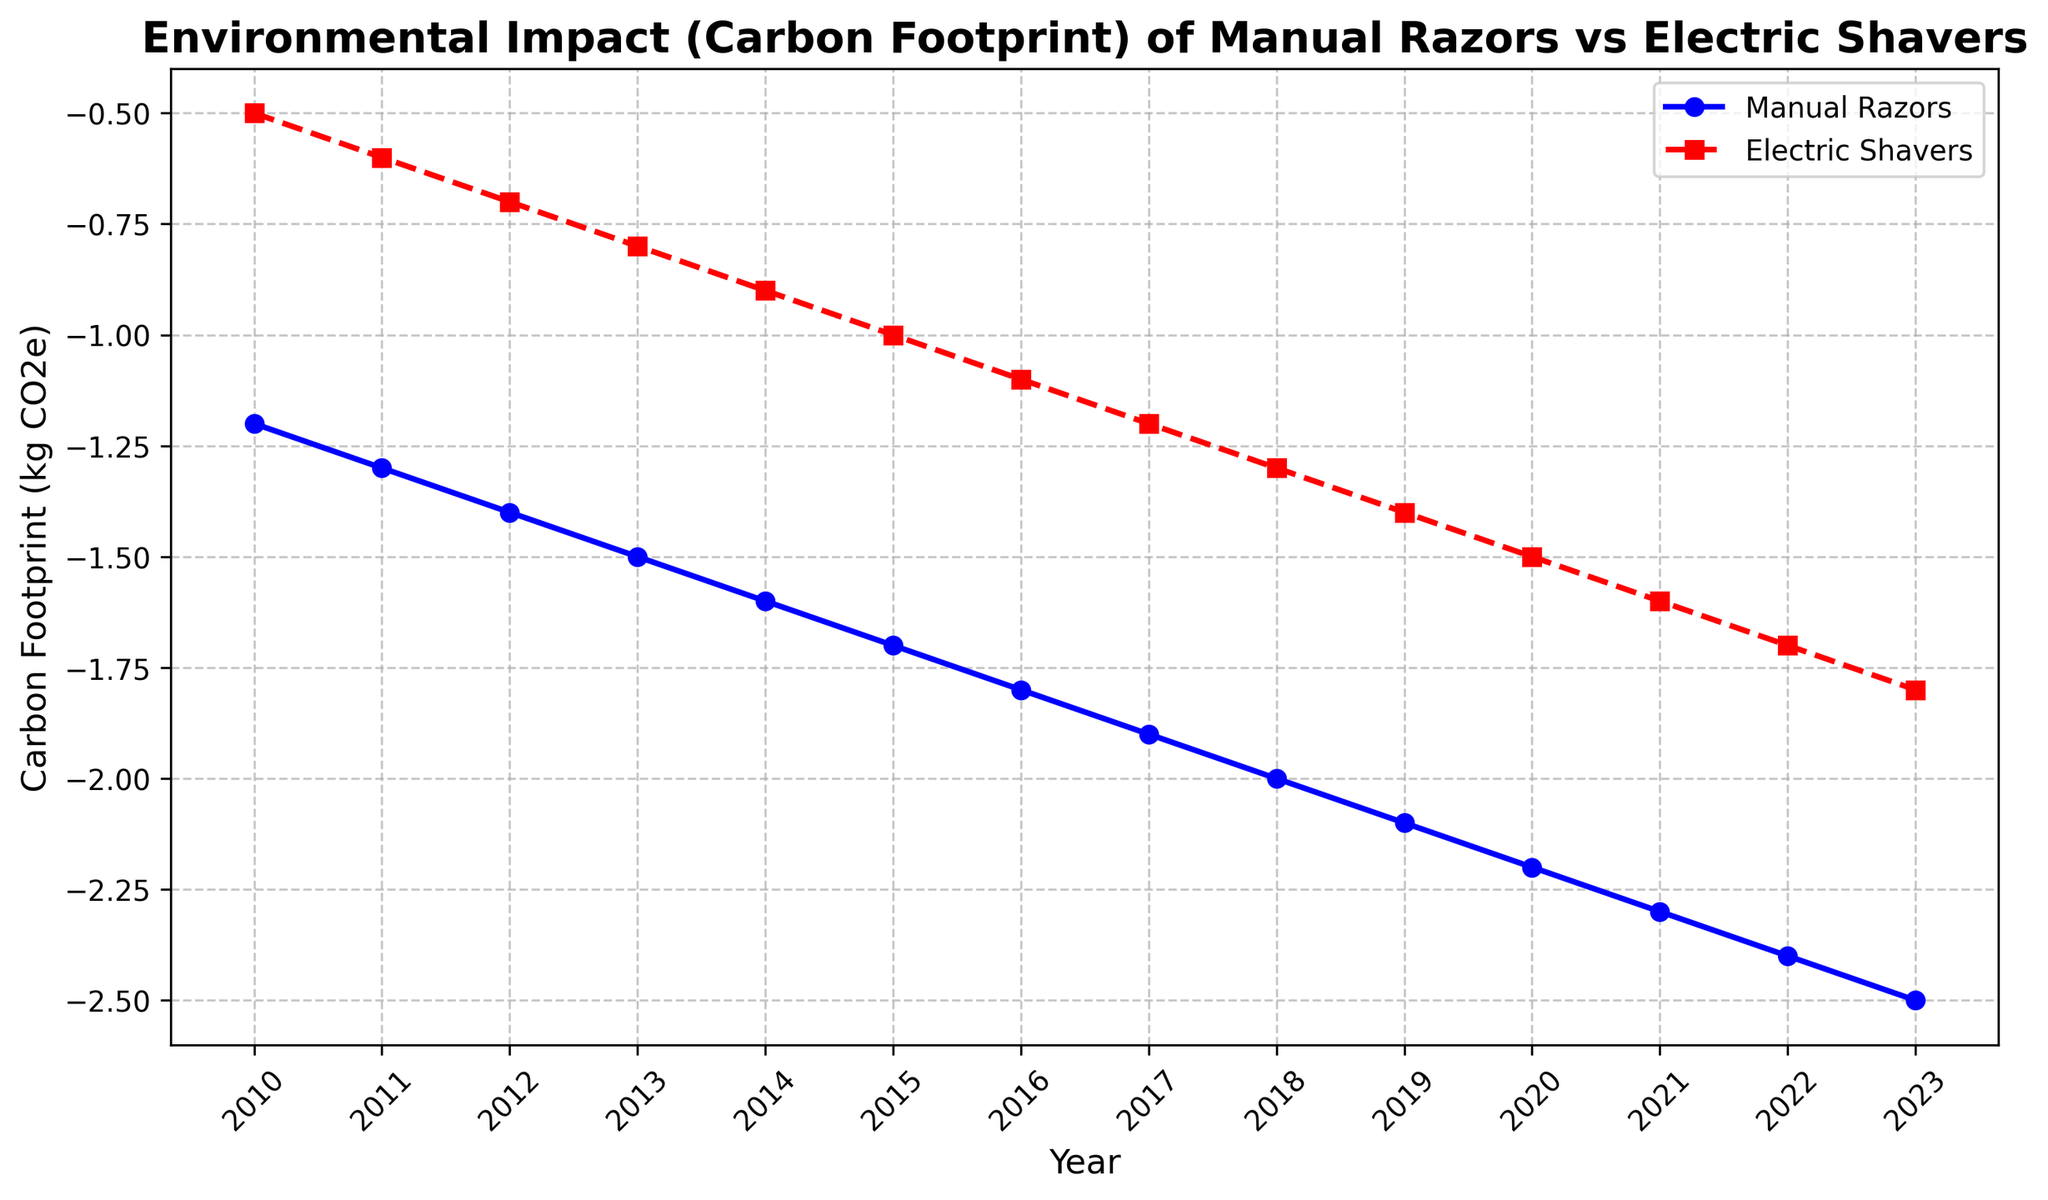What's the difference in carbon footprint between manual razors and electric shavers in 2010? Refer to the figure. In 2010, the carbon footprint for manual razors is -1.2 kg CO2e, and for electric shavers, it is -0.5 kg CO2e. The difference is -1.2 - (-0.5) = -0.7 kg CO2e.
Answer: -0.7 kg CO2e Which year shows the largest carbon footprint difference between manual razors and electric shavers? By examining each year, 2023 has the highest difference. The difference in 2023 is -2.5 - (-1.8) = -0.7, which is consistent with all the years but represents the largest absolute incremental rise.
Answer: 2023 What is the overall trend for both types of razors over the years? The figure shows a downward trend (increase in negative values) for both manual razors and electric shavers. This indicates that the carbon footprint for both types of razors has been decreasing over time.
Answer: Decreasing How much did the carbon footprint for manual razors decrease from 2010 to 2023? In 2010, the carbon footprint for manual razors is -1.2 kg CO2e, and in 2023 it is -2.5 kg CO2e. The decrease is -2.5 - (-1.2) = -1.3 kg CO2e
Answer: -1.3 kg CO2e Compare the decrease in carbon footprint for electric shavers and manual razors from 2015 to 2020. From 2015 to 2020, the carbon footprint for manual razors decreases from -1.7 kg CO2e to -2.2 kg CO2e, which is a difference of -2.2 - (-1.7) = -0.5 kg CO2e. For electric shavers, it decreases from -1.0 kg CO2e to -1.5 kg CO2e, a difference of -1.5 - (-1.0) = -0.5 kg CO2e as well.
Answer: Same decrease (-0.5 kg CO2e) What is the rate of decrease in carbon footprint for electric shavers per year? From 2010 to 2023, the carbon footprint for electric shavers goes from -0.5 kg CO2e to -1.8 kg CO2e. The rate of decrease per year is (-1.8 - (-0.5)) / (2023 - 2010) = -1.3 / 13 ≈ -0.1 kg CO2e per year.
Answer: -0.1 kg CO2e per year Which type of razor shows a more significant reduction in carbon footprint over the period 2010-2023? For manual razors, the decrease from 2010 to 2023 is -1.3 kg CO2e (-2.5 - (-1.2)). For electric shavers, the decrease over the same period is also -1.3 kg CO2e (-1.8 - (-0.5)). Both types show an equal reduction in carbon footprint.
Answer: Both show equal reduction At which year do manual razors and electric shavers show the same annual decrease of carbon footprint? By analyzing the annual rate of decrease for each type, we find that both manual razors and electric shavers show a consistent annual decrease of -0.1 kg CO2e per year through all the years, hence there is no single year where only one shows this pattern.
Answer: Every year 